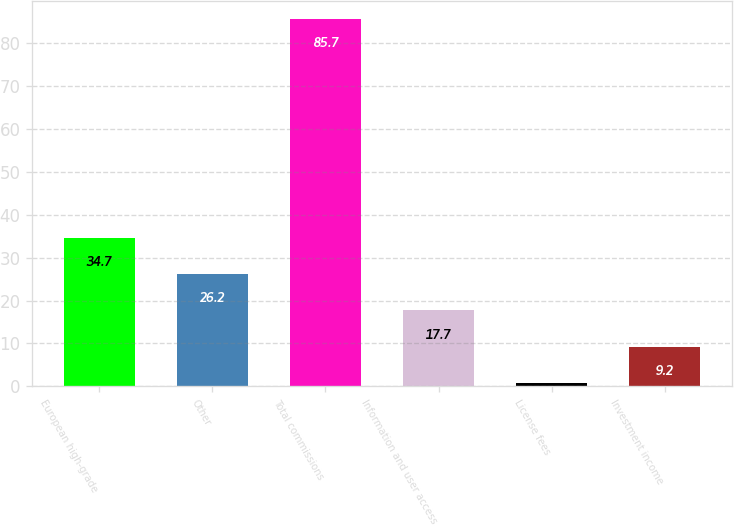<chart> <loc_0><loc_0><loc_500><loc_500><bar_chart><fcel>European high-grade<fcel>Other<fcel>Total commissions<fcel>Information and user access<fcel>License fees<fcel>Investment income<nl><fcel>34.7<fcel>26.2<fcel>85.7<fcel>17.7<fcel>0.7<fcel>9.2<nl></chart> 